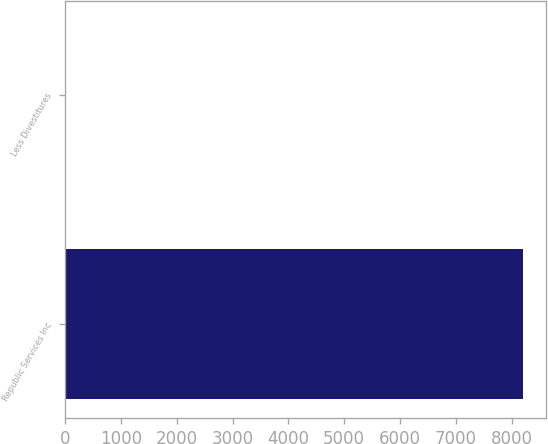<chart> <loc_0><loc_0><loc_500><loc_500><bar_chart><fcel>Republic Services Inc<fcel>Less Divestitures<nl><fcel>8199.1<fcel>9<nl></chart> 